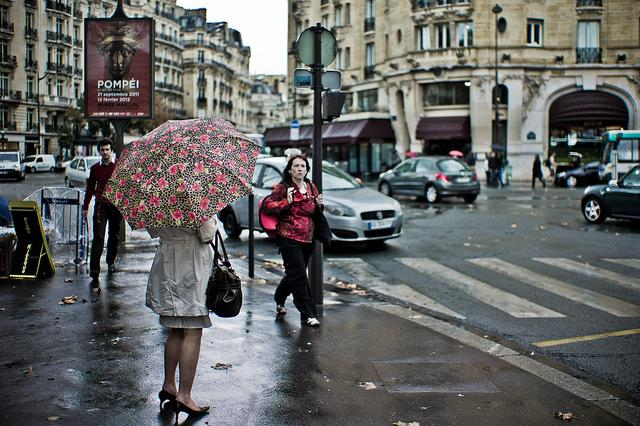When does the Pompeii exhibit end? 2012 